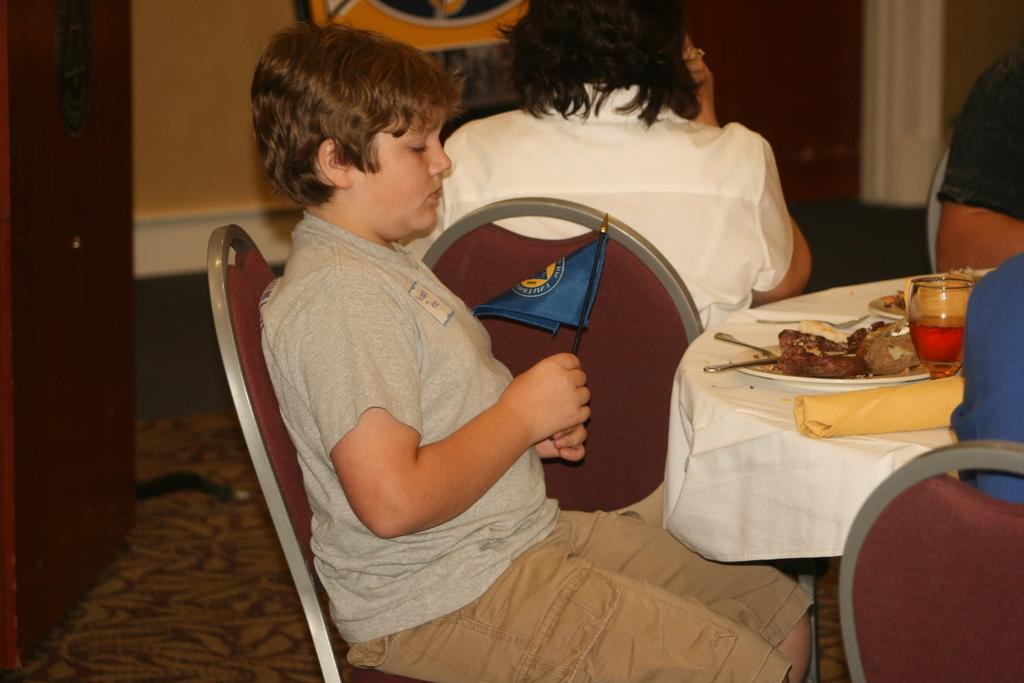Who is the main subject in the image? There is a boy in the image. What is the boy doing in the image? The boy is sitting in chairs and holding a flag. What else can be seen in the image besides the boy? There is a table in the image. What is on the table in the image? Food is served on the table. What type of apple can be seen floating in the waves in the image? There is no apple or waves present in the image; it features a boy sitting in chairs, holding a flag, and a table with food. 